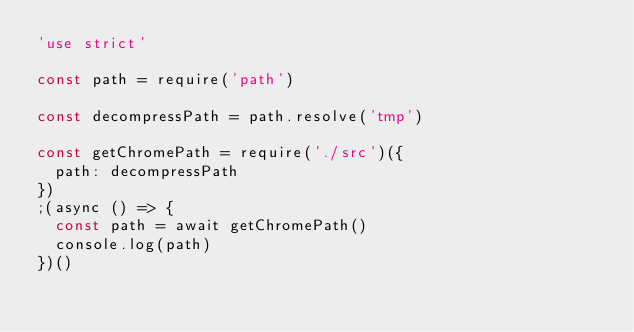<code> <loc_0><loc_0><loc_500><loc_500><_JavaScript_>'use strict'

const path = require('path')

const decompressPath = path.resolve('tmp')

const getChromePath = require('./src')({
  path: decompressPath
})
;(async () => {
  const path = await getChromePath()
  console.log(path)
})()
</code> 